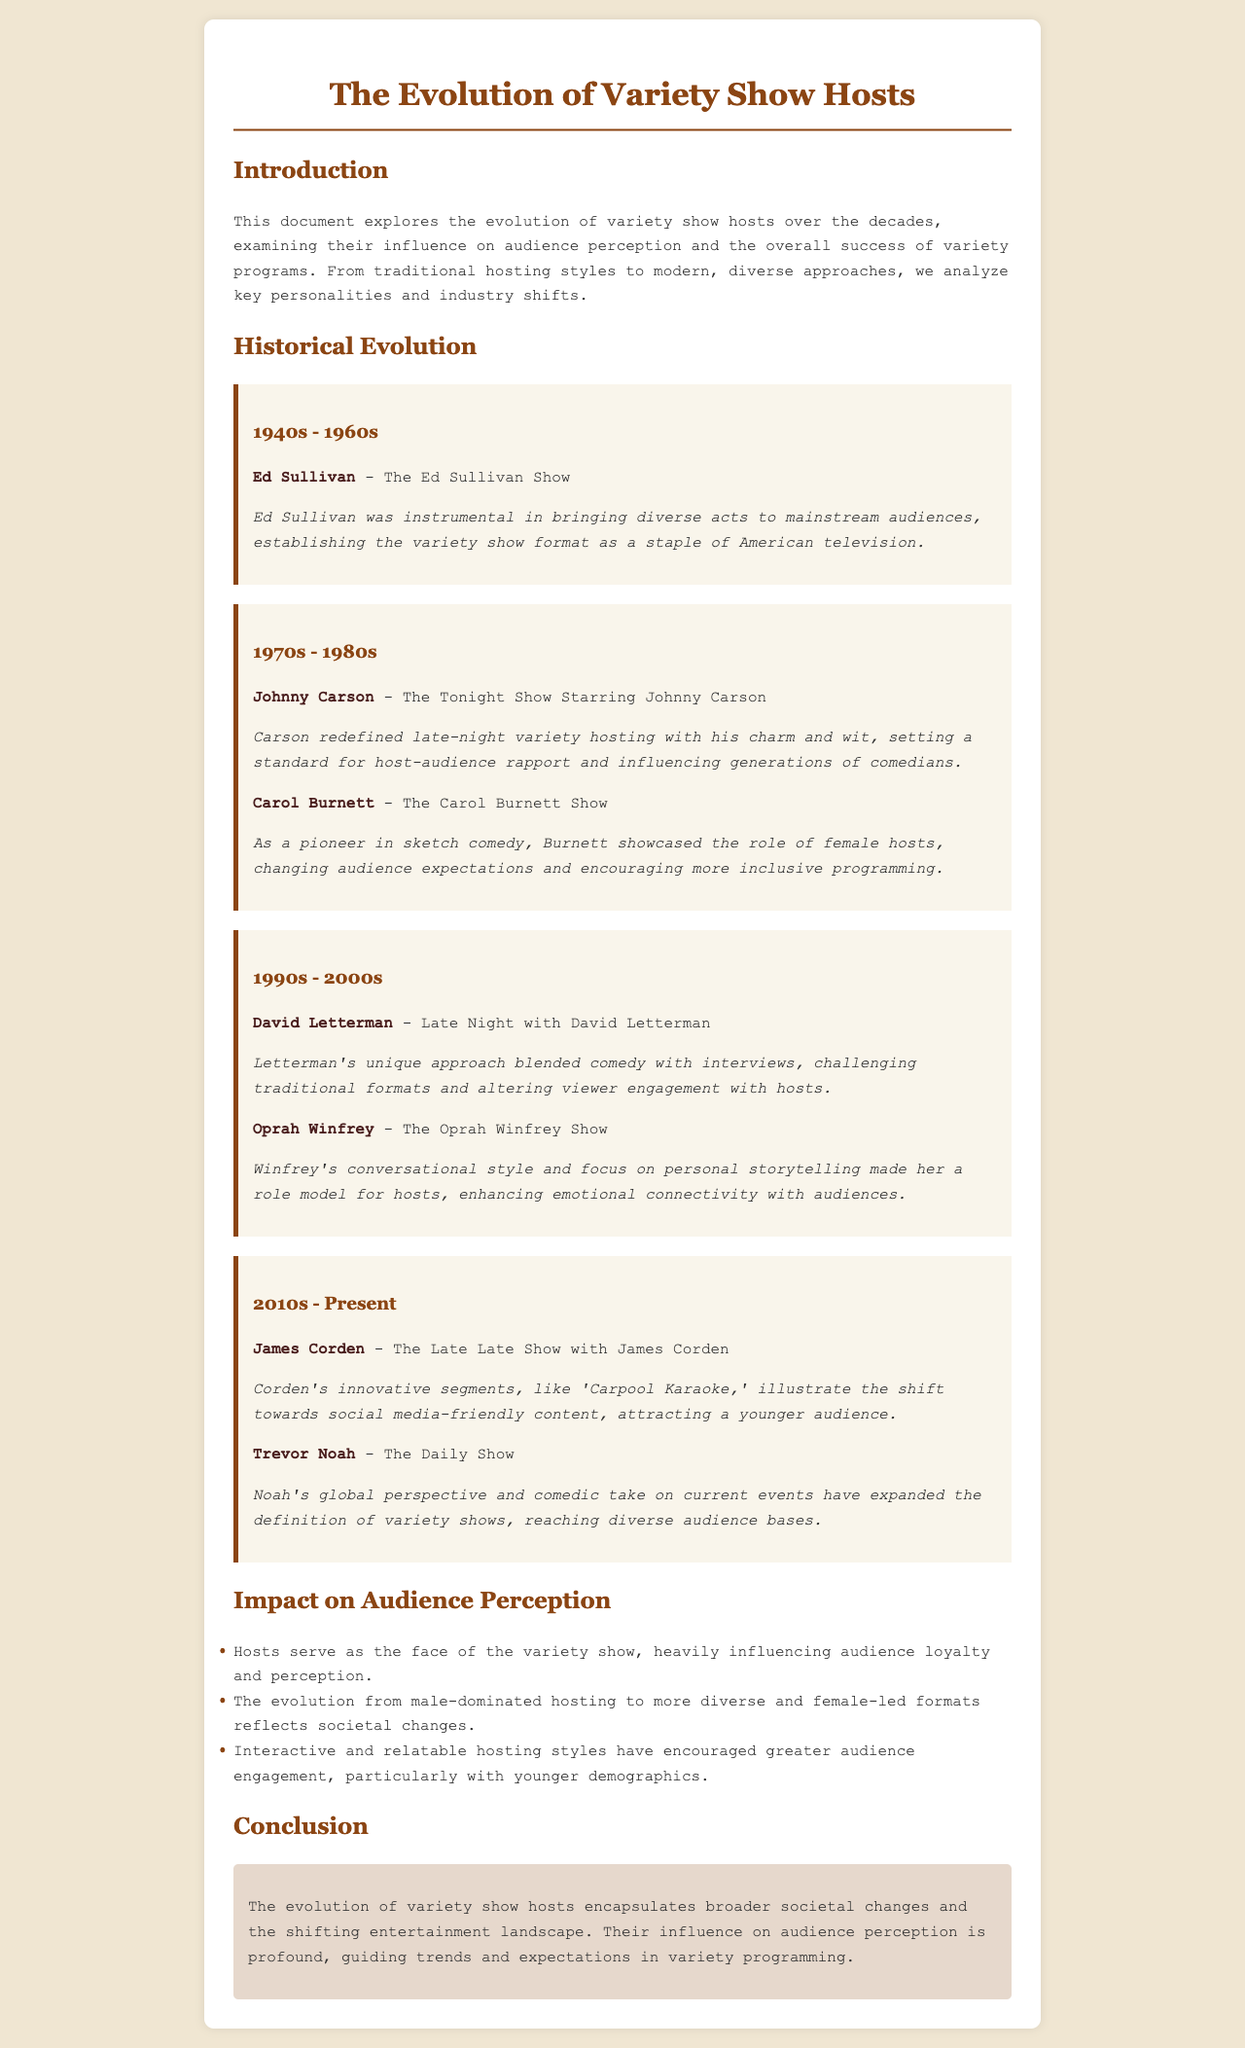What show was hosted by Ed Sullivan? The document states that Ed Sullivan hosted "The Ed Sullivan Show."
Answer: The Ed Sullivan Show During which decades did Johnny Carson host? The document mentions that Johnny Carson hosted during the 1970s and 1980s.
Answer: 1970s - 1980s What was one impact of Carol Burnett's hosting style? The document states that Burnett showcased the role of female hosts and changed audience expectations.
Answer: Changed audience expectations Which host is associated with 'Carpool Karaoke'? The document notes that James Corden is associated with the segment 'Carpool Karaoke.'
Answer: James Corden What is the main focus of Oprah Winfrey's hosting style? The document indicates that Winfrey's focus is on personal storytelling.
Answer: Personal storytelling How have variety show hosts evolved in terms of gender representation? The document discusses the evolution from male-dominated hosting to more diverse and female-led formats.
Answer: More diverse and female-led formats What kind of perspective has Trevor Noah brought to "The Daily Show"? According to the document, Noah's perspective is global and comedic.
Answer: Global perspective What societal changes does the document relate to the evolution of hosts? The document connects broader societal changes to the evolution of variety show hosts.
Answer: Broader societal changes 